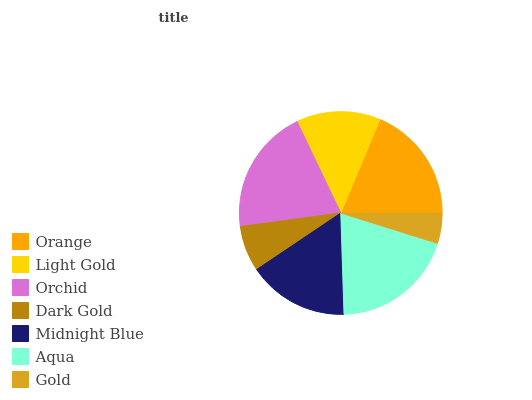Is Gold the minimum?
Answer yes or no. Yes. Is Orchid the maximum?
Answer yes or no. Yes. Is Light Gold the minimum?
Answer yes or no. No. Is Light Gold the maximum?
Answer yes or no. No. Is Orange greater than Light Gold?
Answer yes or no. Yes. Is Light Gold less than Orange?
Answer yes or no. Yes. Is Light Gold greater than Orange?
Answer yes or no. No. Is Orange less than Light Gold?
Answer yes or no. No. Is Midnight Blue the high median?
Answer yes or no. Yes. Is Midnight Blue the low median?
Answer yes or no. Yes. Is Orchid the high median?
Answer yes or no. No. Is Light Gold the low median?
Answer yes or no. No. 